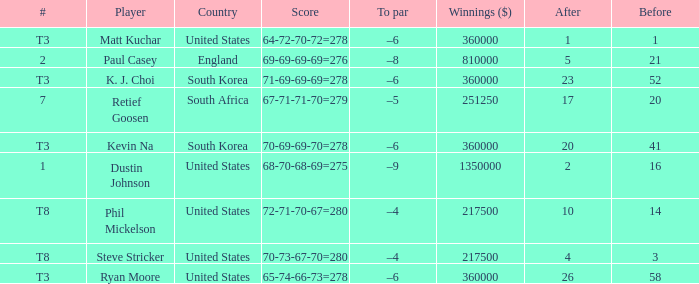What is the player listed when the score is 68-70-68-69=275 Dustin Johnson. 